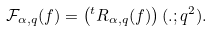<formula> <loc_0><loc_0><loc_500><loc_500>\mathcal { F } _ { \alpha , q } ( f ) = \left ( ^ { t } R _ { \alpha , q } ( f ) \right ) ( . ; q ^ { 2 } ) .</formula> 